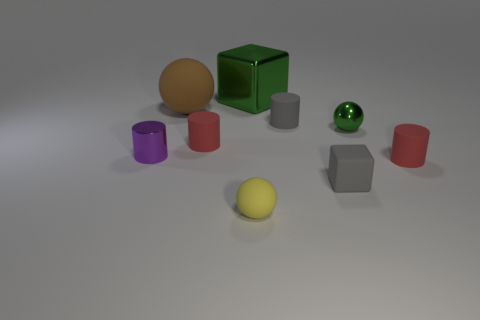Add 1 big cyan things. How many objects exist? 10 Subtract all cylinders. How many objects are left? 5 Add 6 tiny yellow objects. How many tiny yellow objects exist? 7 Subtract 0 brown cylinders. How many objects are left? 9 Subtract all brown rubber things. Subtract all cyan metal cylinders. How many objects are left? 8 Add 3 green metal blocks. How many green metal blocks are left? 4 